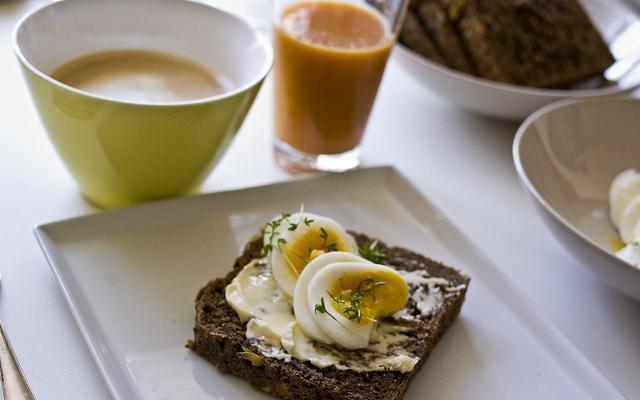How many cups are there?
Give a very brief answer. 2. How many bowls are there?
Give a very brief answer. 2. 